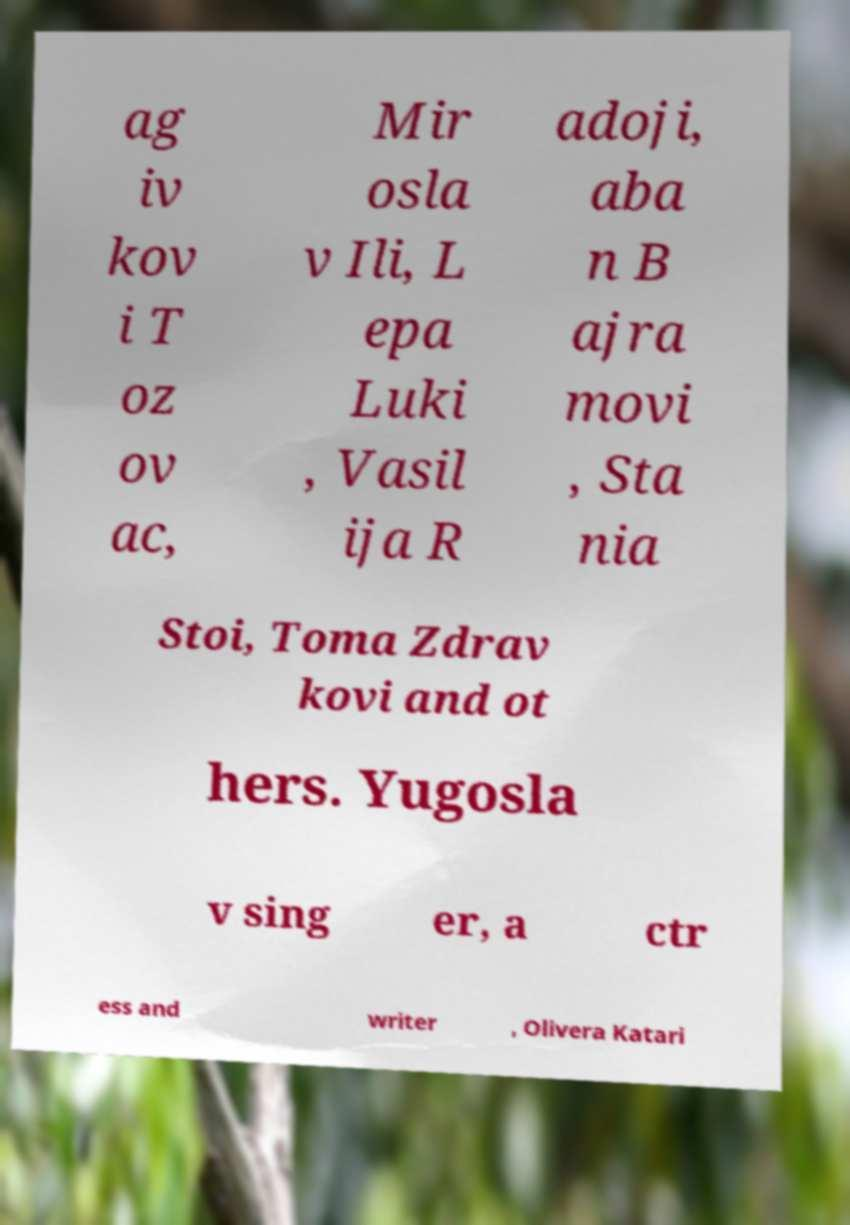I need the written content from this picture converted into text. Can you do that? ag iv kov i T oz ov ac, Mir osla v Ili, L epa Luki , Vasil ija R adoji, aba n B ajra movi , Sta nia Stoi, Toma Zdrav kovi and ot hers. Yugosla v sing er, a ctr ess and writer , Olivera Katari 